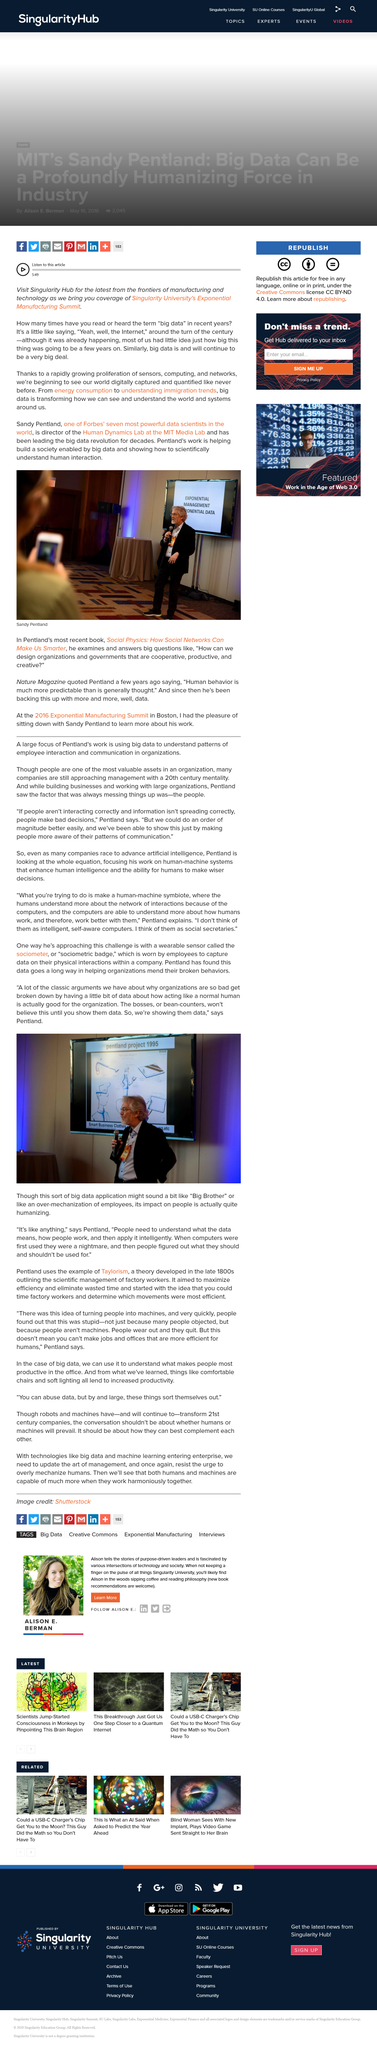List a handful of essential elements in this visual. The sociometer is also known as the sociometric badge. Dr. Sandy Pentland is the director of the Human Dynamics Lab at the MIT Media Lab. The person in the photograph is a man, and his name is Sandy Pentland. Pentland talked about the sociometer. The sociometer is a wearable sensor that is worn by employees to collect data on their physical interactions within a company. 